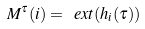<formula> <loc_0><loc_0><loc_500><loc_500>M ^ { \tau } ( i ) = \ e x t ( h _ { i } ( \tau ) )</formula> 